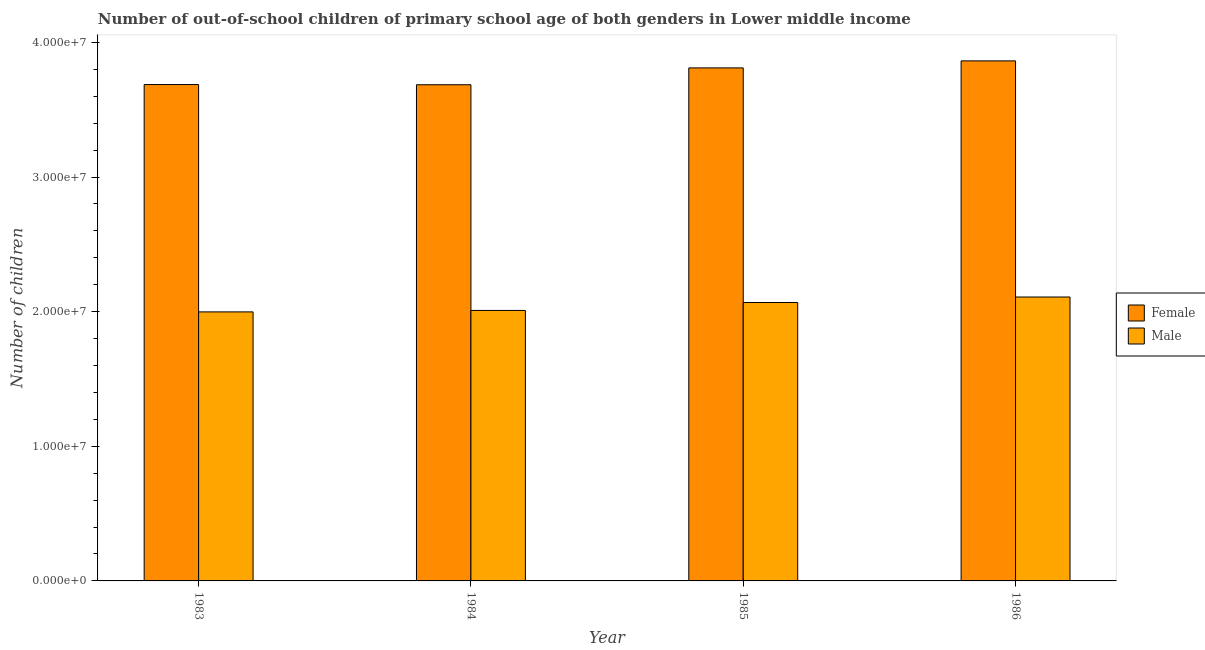Are the number of bars per tick equal to the number of legend labels?
Your answer should be very brief. Yes. How many bars are there on the 2nd tick from the right?
Provide a short and direct response. 2. What is the label of the 1st group of bars from the left?
Give a very brief answer. 1983. What is the number of female out-of-school students in 1984?
Give a very brief answer. 3.69e+07. Across all years, what is the maximum number of male out-of-school students?
Keep it short and to the point. 2.11e+07. Across all years, what is the minimum number of female out-of-school students?
Make the answer very short. 3.69e+07. In which year was the number of male out-of-school students maximum?
Keep it short and to the point. 1986. In which year was the number of male out-of-school students minimum?
Ensure brevity in your answer.  1983. What is the total number of female out-of-school students in the graph?
Your response must be concise. 1.50e+08. What is the difference between the number of female out-of-school students in 1984 and that in 1986?
Offer a terse response. -1.77e+06. What is the difference between the number of female out-of-school students in 1985 and the number of male out-of-school students in 1983?
Ensure brevity in your answer.  1.24e+06. What is the average number of male out-of-school students per year?
Keep it short and to the point. 2.05e+07. In the year 1985, what is the difference between the number of female out-of-school students and number of male out-of-school students?
Offer a very short reply. 0. What is the ratio of the number of female out-of-school students in 1984 to that in 1985?
Offer a very short reply. 0.97. Is the difference between the number of female out-of-school students in 1983 and 1984 greater than the difference between the number of male out-of-school students in 1983 and 1984?
Make the answer very short. No. What is the difference between the highest and the second highest number of female out-of-school students?
Make the answer very short. 5.22e+05. What is the difference between the highest and the lowest number of male out-of-school students?
Make the answer very short. 1.11e+06. In how many years, is the number of female out-of-school students greater than the average number of female out-of-school students taken over all years?
Provide a succinct answer. 2. What does the 2nd bar from the left in 1983 represents?
Provide a short and direct response. Male. What does the 2nd bar from the right in 1983 represents?
Your answer should be compact. Female. How many bars are there?
Your answer should be very brief. 8. Does the graph contain any zero values?
Offer a very short reply. No. Where does the legend appear in the graph?
Offer a very short reply. Center right. How are the legend labels stacked?
Your response must be concise. Vertical. What is the title of the graph?
Your answer should be compact. Number of out-of-school children of primary school age of both genders in Lower middle income. Does "Female entrants" appear as one of the legend labels in the graph?
Offer a very short reply. No. What is the label or title of the Y-axis?
Offer a very short reply. Number of children. What is the Number of children in Female in 1983?
Keep it short and to the point. 3.69e+07. What is the Number of children of Male in 1983?
Your answer should be compact. 2.00e+07. What is the Number of children of Female in 1984?
Ensure brevity in your answer.  3.69e+07. What is the Number of children of Male in 1984?
Your answer should be compact. 2.01e+07. What is the Number of children in Female in 1985?
Provide a short and direct response. 3.81e+07. What is the Number of children of Male in 1985?
Keep it short and to the point. 2.07e+07. What is the Number of children of Female in 1986?
Give a very brief answer. 3.86e+07. What is the Number of children in Male in 1986?
Your response must be concise. 2.11e+07. Across all years, what is the maximum Number of children in Female?
Give a very brief answer. 3.86e+07. Across all years, what is the maximum Number of children of Male?
Provide a short and direct response. 2.11e+07. Across all years, what is the minimum Number of children of Female?
Give a very brief answer. 3.69e+07. Across all years, what is the minimum Number of children of Male?
Offer a terse response. 2.00e+07. What is the total Number of children of Female in the graph?
Offer a very short reply. 1.50e+08. What is the total Number of children of Male in the graph?
Provide a succinct answer. 8.18e+07. What is the difference between the Number of children of Female in 1983 and that in 1984?
Your answer should be compact. 1.52e+04. What is the difference between the Number of children in Male in 1983 and that in 1984?
Your response must be concise. -1.09e+05. What is the difference between the Number of children of Female in 1983 and that in 1985?
Make the answer very short. -1.24e+06. What is the difference between the Number of children in Male in 1983 and that in 1985?
Keep it short and to the point. -6.96e+05. What is the difference between the Number of children of Female in 1983 and that in 1986?
Your answer should be compact. -1.76e+06. What is the difference between the Number of children in Male in 1983 and that in 1986?
Your response must be concise. -1.11e+06. What is the difference between the Number of children of Female in 1984 and that in 1985?
Provide a succinct answer. -1.25e+06. What is the difference between the Number of children of Male in 1984 and that in 1985?
Your answer should be very brief. -5.87e+05. What is the difference between the Number of children in Female in 1984 and that in 1986?
Your answer should be compact. -1.77e+06. What is the difference between the Number of children in Male in 1984 and that in 1986?
Make the answer very short. -9.97e+05. What is the difference between the Number of children of Female in 1985 and that in 1986?
Provide a succinct answer. -5.22e+05. What is the difference between the Number of children in Male in 1985 and that in 1986?
Provide a succinct answer. -4.10e+05. What is the difference between the Number of children of Female in 1983 and the Number of children of Male in 1984?
Your response must be concise. 1.68e+07. What is the difference between the Number of children in Female in 1983 and the Number of children in Male in 1985?
Make the answer very short. 1.62e+07. What is the difference between the Number of children of Female in 1983 and the Number of children of Male in 1986?
Provide a short and direct response. 1.58e+07. What is the difference between the Number of children in Female in 1984 and the Number of children in Male in 1985?
Give a very brief answer. 1.62e+07. What is the difference between the Number of children in Female in 1984 and the Number of children in Male in 1986?
Offer a terse response. 1.58e+07. What is the difference between the Number of children of Female in 1985 and the Number of children of Male in 1986?
Your response must be concise. 1.70e+07. What is the average Number of children in Female per year?
Keep it short and to the point. 3.76e+07. What is the average Number of children of Male per year?
Offer a very short reply. 2.05e+07. In the year 1983, what is the difference between the Number of children of Female and Number of children of Male?
Your answer should be very brief. 1.69e+07. In the year 1984, what is the difference between the Number of children in Female and Number of children in Male?
Offer a terse response. 1.68e+07. In the year 1985, what is the difference between the Number of children in Female and Number of children in Male?
Keep it short and to the point. 1.74e+07. In the year 1986, what is the difference between the Number of children in Female and Number of children in Male?
Provide a short and direct response. 1.75e+07. What is the ratio of the Number of children of Female in 1983 to that in 1984?
Your response must be concise. 1. What is the ratio of the Number of children of Female in 1983 to that in 1985?
Offer a terse response. 0.97. What is the ratio of the Number of children in Male in 1983 to that in 1985?
Make the answer very short. 0.97. What is the ratio of the Number of children in Female in 1983 to that in 1986?
Ensure brevity in your answer.  0.95. What is the ratio of the Number of children in Male in 1983 to that in 1986?
Provide a short and direct response. 0.95. What is the ratio of the Number of children of Female in 1984 to that in 1985?
Ensure brevity in your answer.  0.97. What is the ratio of the Number of children in Male in 1984 to that in 1985?
Give a very brief answer. 0.97. What is the ratio of the Number of children in Female in 1984 to that in 1986?
Offer a terse response. 0.95. What is the ratio of the Number of children of Male in 1984 to that in 1986?
Ensure brevity in your answer.  0.95. What is the ratio of the Number of children of Female in 1985 to that in 1986?
Offer a very short reply. 0.99. What is the ratio of the Number of children of Male in 1985 to that in 1986?
Offer a very short reply. 0.98. What is the difference between the highest and the second highest Number of children of Female?
Provide a succinct answer. 5.22e+05. What is the difference between the highest and the second highest Number of children of Male?
Your answer should be compact. 4.10e+05. What is the difference between the highest and the lowest Number of children in Female?
Provide a succinct answer. 1.77e+06. What is the difference between the highest and the lowest Number of children of Male?
Make the answer very short. 1.11e+06. 